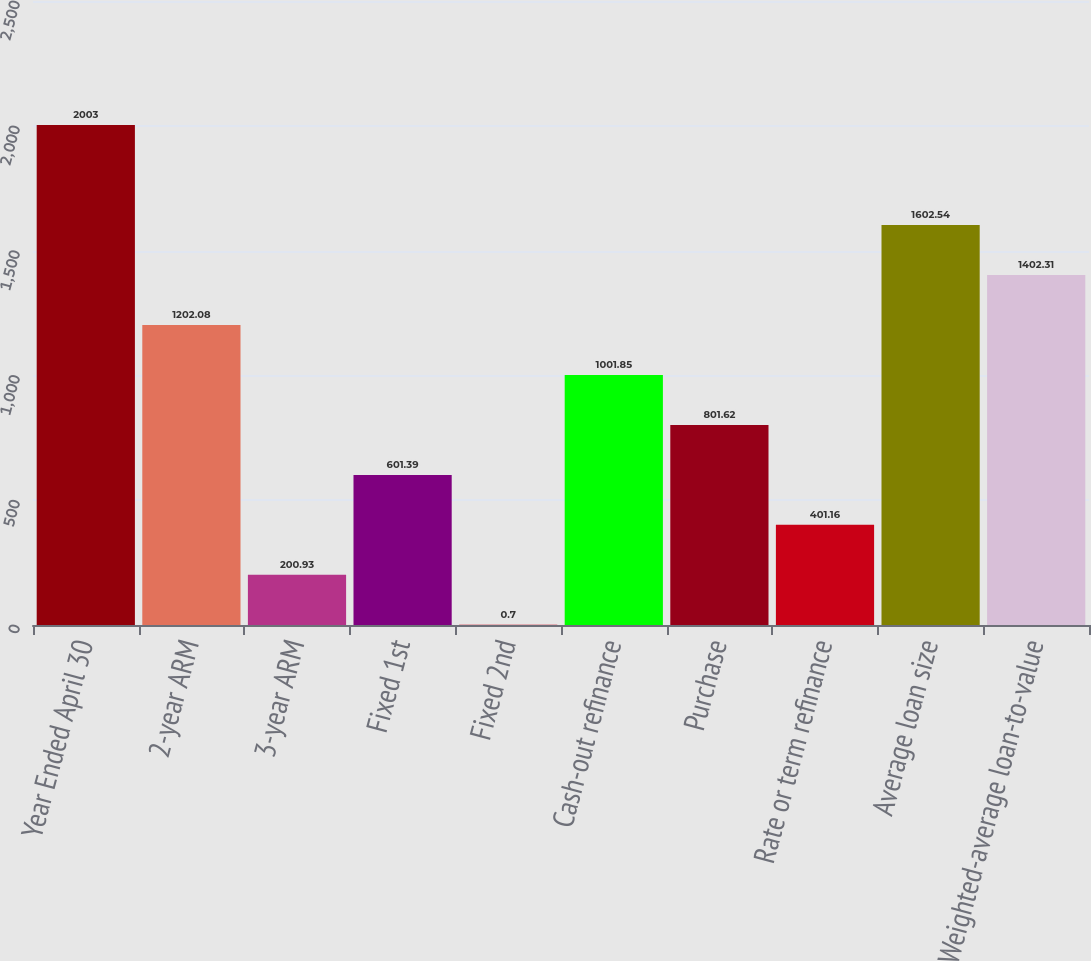Convert chart. <chart><loc_0><loc_0><loc_500><loc_500><bar_chart><fcel>Year Ended April 30<fcel>2-year ARM<fcel>3-year ARM<fcel>Fixed 1st<fcel>Fixed 2nd<fcel>Cash-out refinance<fcel>Purchase<fcel>Rate or term refinance<fcel>Average loan size<fcel>Weighted-average loan-to-value<nl><fcel>2003<fcel>1202.08<fcel>200.93<fcel>601.39<fcel>0.7<fcel>1001.85<fcel>801.62<fcel>401.16<fcel>1602.54<fcel>1402.31<nl></chart> 